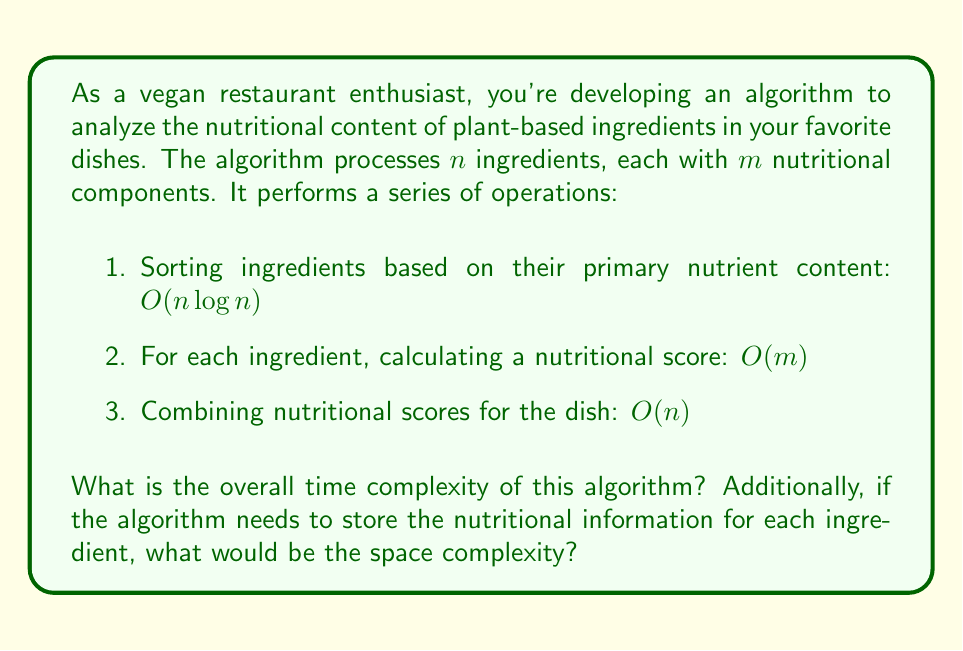Teach me how to tackle this problem. Let's break down the time complexity analysis step by step:

1. Sorting ingredients: $O(n \log n)$
   This is typically the time complexity for efficient sorting algorithms like Merge Sort or Quick Sort.

2. Calculating nutritional scores: $O(nm)$
   For each of the $n$ ingredients, we perform $m$ operations to calculate the nutritional score.

3. Combining nutritional scores: $O(n)$
   We iterate through all $n$ ingredients once to combine their scores.

To determine the overall time complexity, we add these components:

$$O(n \log n) + O(nm) + O(n)$$

The dominant term in this expression depends on the relative sizes of $n$ and $m$. In most practical scenarios for nutritional analysis, $m$ (the number of nutritional components) is likely to be smaller than $n$ (the number of ingredients) and can be considered a constant. In this case, the time complexity simplifies to:

$$O(n \log n) + O(n) + O(n) = O(n \log n)$$

For the space complexity:
The algorithm needs to store information for each ingredient and its nutritional components. This requires an array or similar data structure of size $n \times m$. Therefore, the space complexity is $O(nm)$.

If $m$ is considered constant, this simplifies to $O(n)$.
Answer: Time complexity: $O(n \log n)$
Space complexity: $O(nm)$, or $O(n)$ if $m$ is constant 